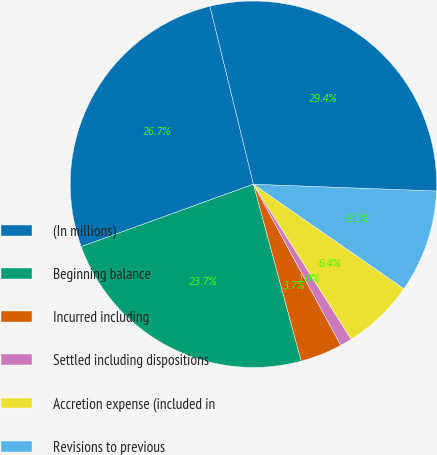Convert chart. <chart><loc_0><loc_0><loc_500><loc_500><pie_chart><fcel>(In millions)<fcel>Beginning balance<fcel>Incurred including<fcel>Settled including dispositions<fcel>Accretion expense (included in<fcel>Revisions to previous<fcel>Ending balance (b)<nl><fcel>26.72%<fcel>23.67%<fcel>3.71%<fcel>1.04%<fcel>6.39%<fcel>9.07%<fcel>29.4%<nl></chart> 